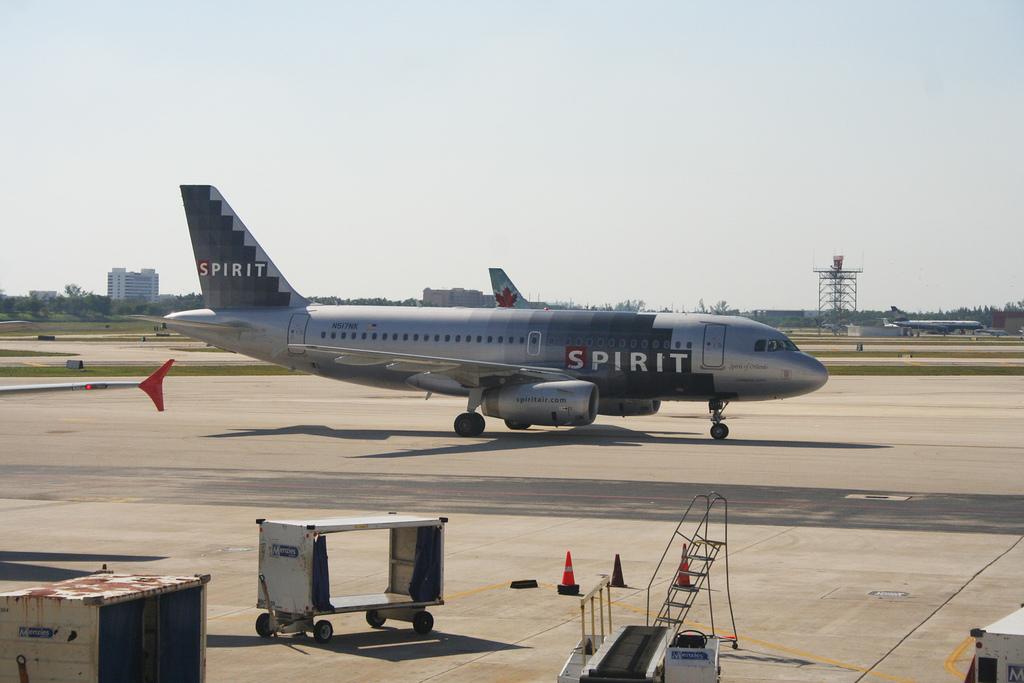What is the airline?
Ensure brevity in your answer.  Spirit. 